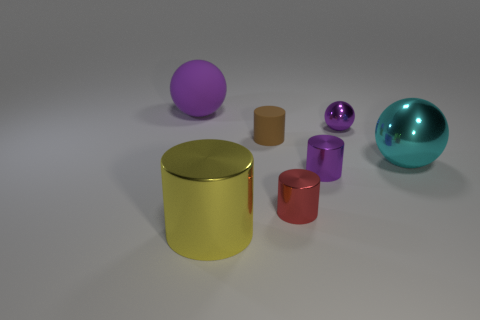What time of day does the lighting in this image suggest? The lighting in the image doesn't strongly indicate a specific time of day. It appears to be studio lighting with a neutral backdrop, designed to highlight the objects without any natural lighting cues such as warm evening light or cool morning light. 